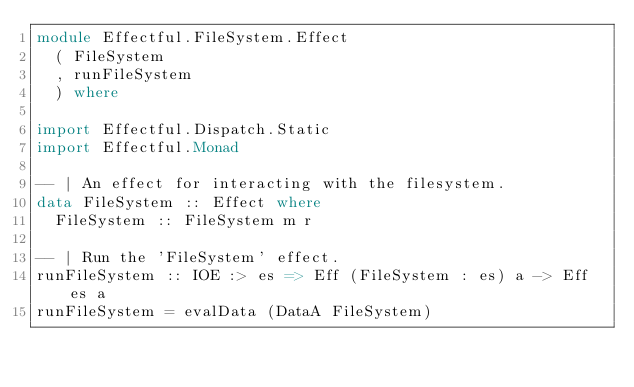<code> <loc_0><loc_0><loc_500><loc_500><_Haskell_>module Effectful.FileSystem.Effect
  ( FileSystem
  , runFileSystem
  ) where

import Effectful.Dispatch.Static
import Effectful.Monad

-- | An effect for interacting with the filesystem.
data FileSystem :: Effect where
  FileSystem :: FileSystem m r

-- | Run the 'FileSystem' effect.
runFileSystem :: IOE :> es => Eff (FileSystem : es) a -> Eff es a
runFileSystem = evalData (DataA FileSystem)
</code> 